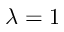<formula> <loc_0><loc_0><loc_500><loc_500>\lambda = 1</formula> 